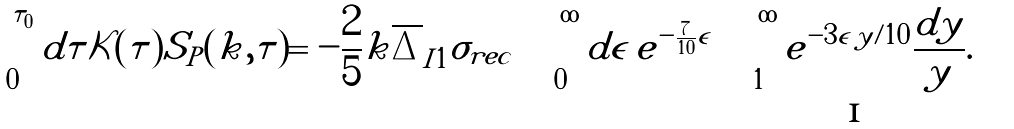<formula> <loc_0><loc_0><loc_500><loc_500>\int _ { 0 } ^ { \tau _ { 0 } } d \tau { \mathcal { K } } ( \tau ) S _ { P } ( k , \tau ) = - \frac { 2 } { 5 } k \overline { \Delta } _ { I 1 } \sigma _ { r e c } \int _ { 0 } ^ { \infty } d \epsilon \, e ^ { - \frac { 7 } { 1 0 } \epsilon } \int _ { 1 } ^ { \infty } e ^ { - 3 \epsilon \, y / 1 0 } \frac { d y } { y } .</formula> 